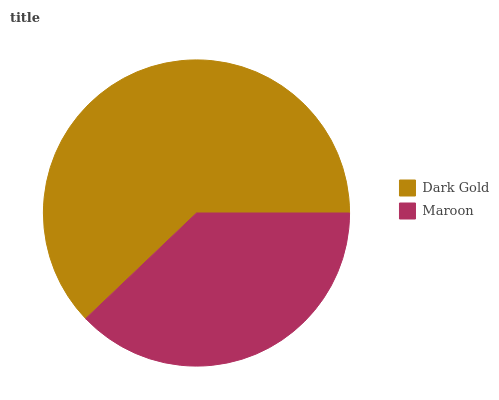Is Maroon the minimum?
Answer yes or no. Yes. Is Dark Gold the maximum?
Answer yes or no. Yes. Is Maroon the maximum?
Answer yes or no. No. Is Dark Gold greater than Maroon?
Answer yes or no. Yes. Is Maroon less than Dark Gold?
Answer yes or no. Yes. Is Maroon greater than Dark Gold?
Answer yes or no. No. Is Dark Gold less than Maroon?
Answer yes or no. No. Is Dark Gold the high median?
Answer yes or no. Yes. Is Maroon the low median?
Answer yes or no. Yes. Is Maroon the high median?
Answer yes or no. No. Is Dark Gold the low median?
Answer yes or no. No. 